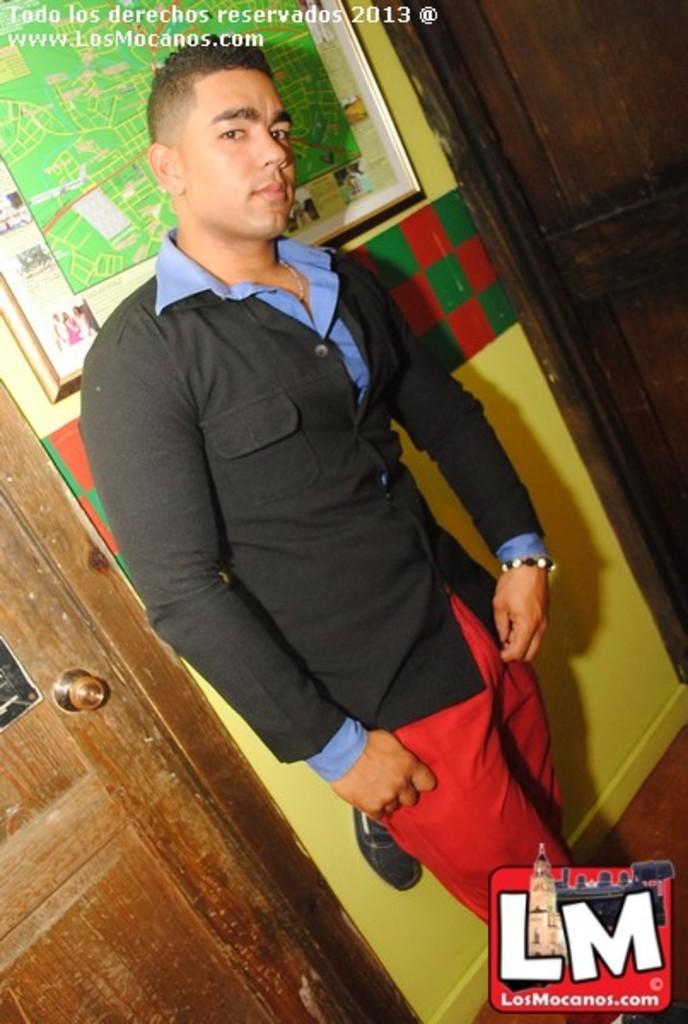Please provide a concise description of this image. In this image, we can see a person is standing and watching. Background there is a wall, doors, handle, photo frame. Right side bottom, there is a logo and floor. Top of the aimed, we can see some text. 